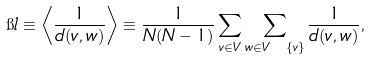Convert formula to latex. <formula><loc_0><loc_0><loc_500><loc_500>\i l \equiv \left \langle \frac { 1 } { d ( v , w ) } \right \rangle \equiv \frac { 1 } { N ( N - 1 ) } \sum _ { v \in V } \sum _ { w \in V \ \{ v \} } \frac { 1 } { d ( v , w ) } ,</formula> 